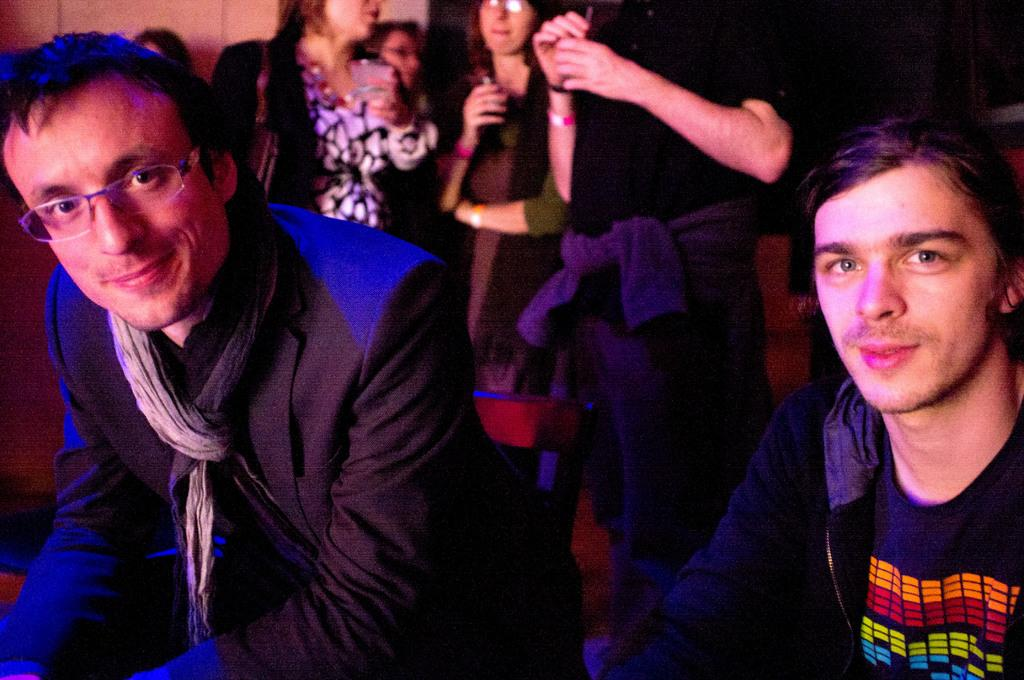How many people are in the foreground of the picture? There are two men in the foreground of the picture. What can be observed about the background of the image? The background of the image is blurred. Can you describe the people in the background of the image? There are people standing in the background of the image. What type of birthday money is the man in the foreground holding in the image? There is no money or reference to a birthday present in the image; it only features two men in the foreground and people in the background. 